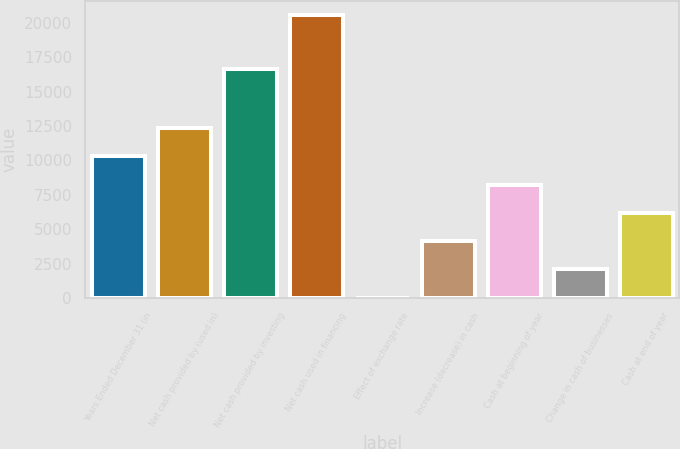Convert chart to OTSL. <chart><loc_0><loc_0><loc_500><loc_500><bar_chart><fcel>Years Ended December 31 (in<fcel>Net cash provided by (used in)<fcel>Net cash provided by investing<fcel>Net cash used in financing<fcel>Effect of exchange rate<fcel>Increase (decrease) in cash<fcel>Cash at beginning of year<fcel>Change in cash of businesses<fcel>Cash at end of year<nl><fcel>10290<fcel>12344.8<fcel>16612<fcel>20564<fcel>16<fcel>4125.6<fcel>8235.2<fcel>2070.8<fcel>6180.4<nl></chart> 